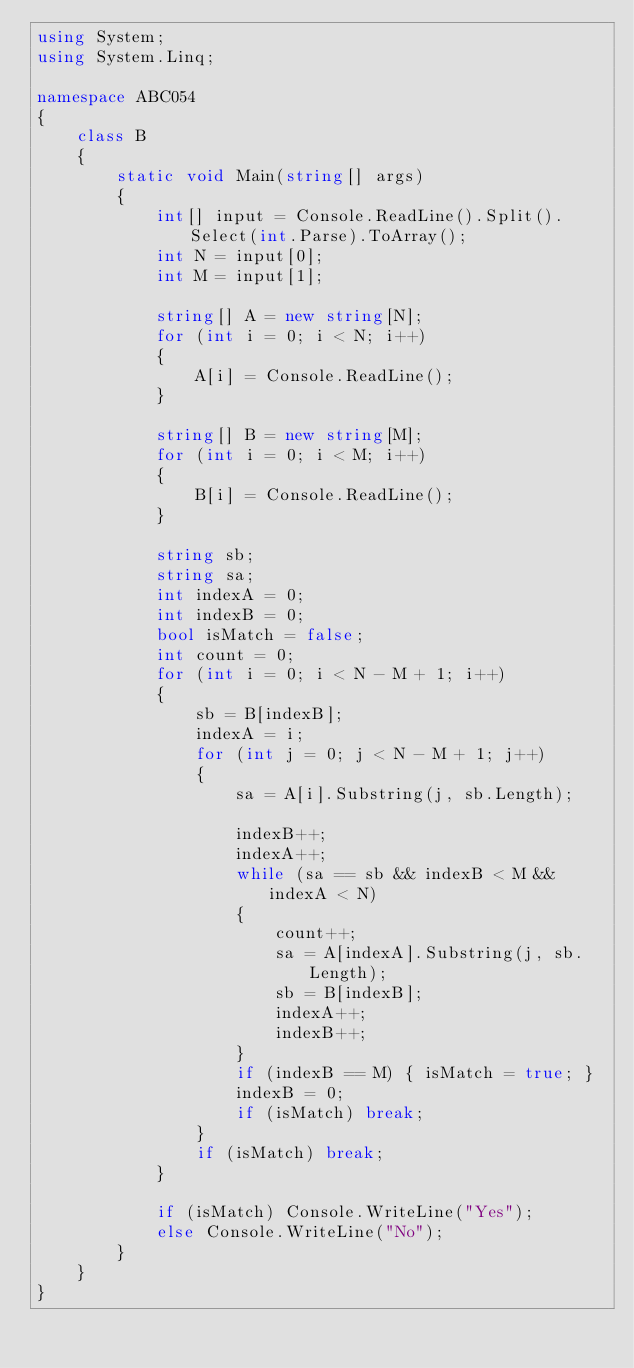<code> <loc_0><loc_0><loc_500><loc_500><_C#_>using System;
using System.Linq;

namespace ABC054
{
    class B
    {
        static void Main(string[] args)
        {
            int[] input = Console.ReadLine().Split().Select(int.Parse).ToArray();
            int N = input[0];
            int M = input[1];

            string[] A = new string[N];
            for (int i = 0; i < N; i++)
            {
                A[i] = Console.ReadLine();
            }

            string[] B = new string[M];
            for (int i = 0; i < M; i++)
            {
                B[i] = Console.ReadLine();
            }

            string sb;
            string sa;
            int indexA = 0;
            int indexB = 0;
            bool isMatch = false;
            int count = 0;
            for (int i = 0; i < N - M + 1; i++)
            {
                sb = B[indexB];
                indexA = i;
                for (int j = 0; j < N - M + 1; j++)
                {
                    sa = A[i].Substring(j, sb.Length);

                    indexB++;
                    indexA++;
                    while (sa == sb && indexB < M && indexA < N)
                    {
                        count++;
                        sa = A[indexA].Substring(j, sb.Length);
                        sb = B[indexB];
                        indexA++;
                        indexB++;
                    }
                    if (indexB == M) { isMatch = true; }
                    indexB = 0;
                    if (isMatch) break;
                }
                if (isMatch) break;
            }

            if (isMatch) Console.WriteLine("Yes");
            else Console.WriteLine("No");
        }
    }
}
</code> 